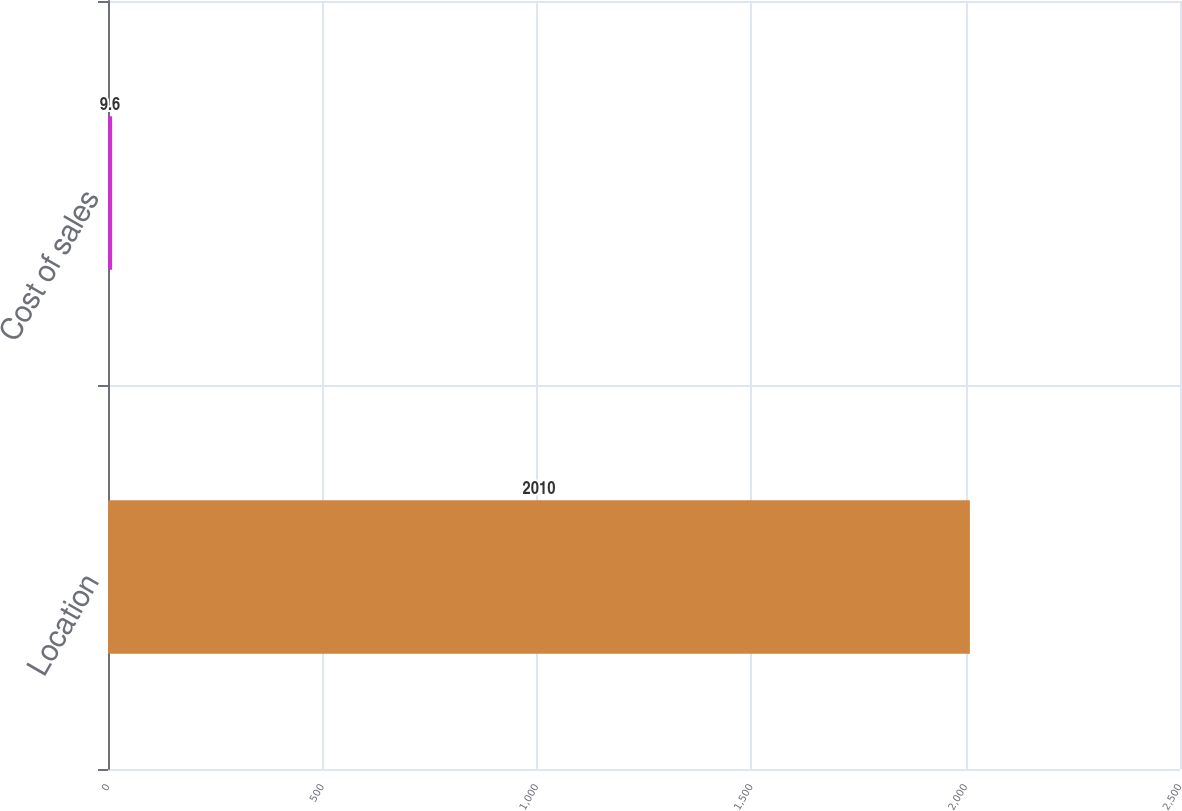Convert chart. <chart><loc_0><loc_0><loc_500><loc_500><bar_chart><fcel>Location<fcel>Cost of sales<nl><fcel>2010<fcel>9.6<nl></chart> 